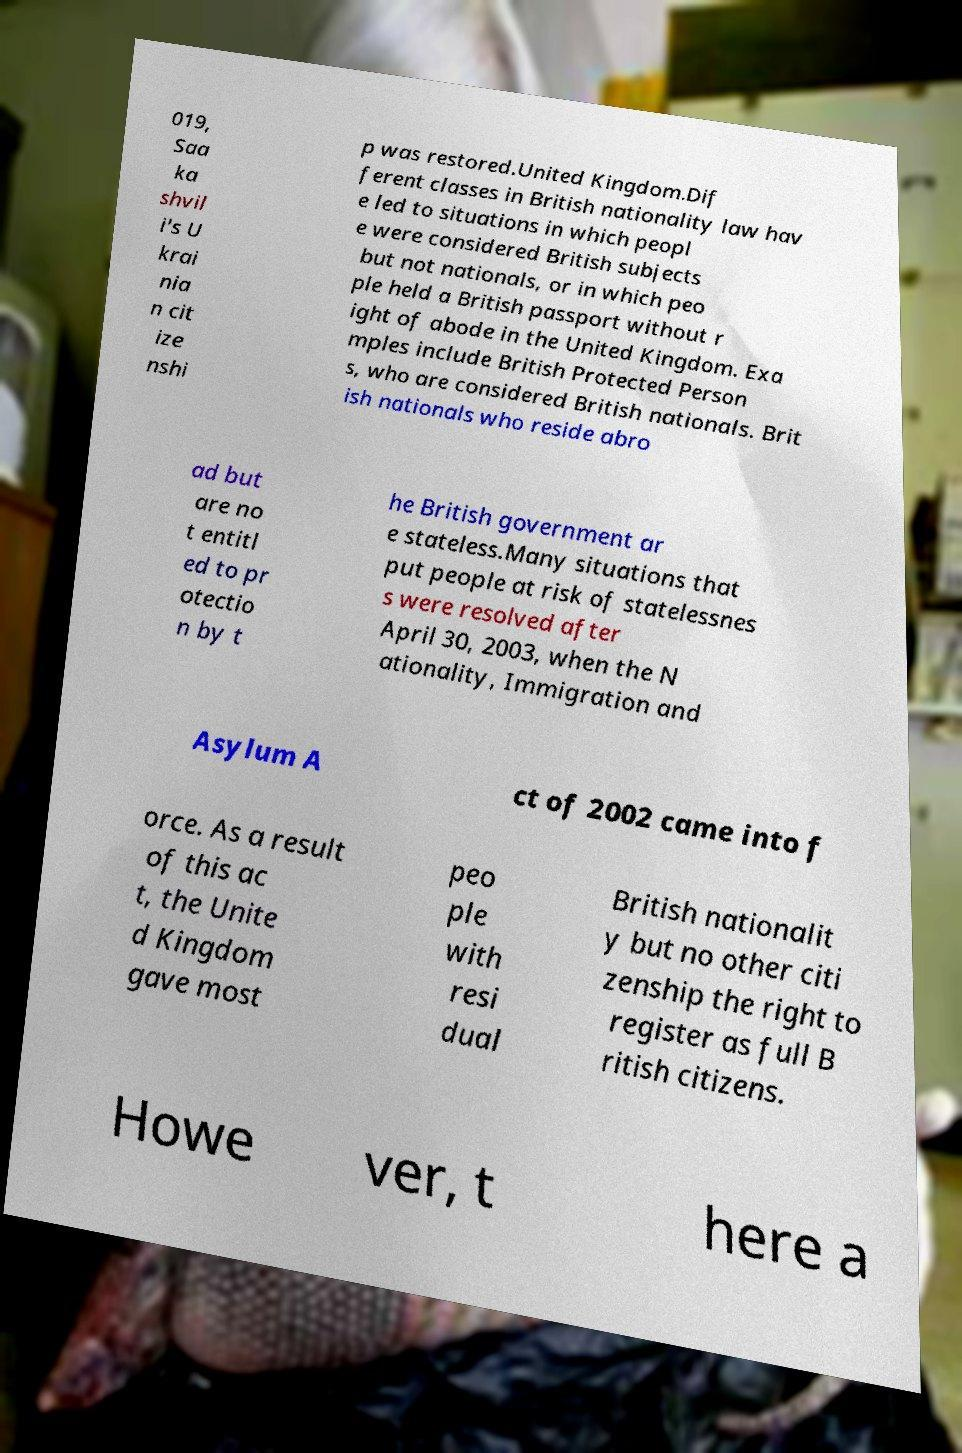For documentation purposes, I need the text within this image transcribed. Could you provide that? 019, Saa ka shvil i's U krai nia n cit ize nshi p was restored.United Kingdom.Dif ferent classes in British nationality law hav e led to situations in which peopl e were considered British subjects but not nationals, or in which peo ple held a British passport without r ight of abode in the United Kingdom. Exa mples include British Protected Person s, who are considered British nationals. Brit ish nationals who reside abro ad but are no t entitl ed to pr otectio n by t he British government ar e stateless.Many situations that put people at risk of statelessnes s were resolved after April 30, 2003, when the N ationality, Immigration and Asylum A ct of 2002 came into f orce. As a result of this ac t, the Unite d Kingdom gave most peo ple with resi dual British nationalit y but no other citi zenship the right to register as full B ritish citizens. Howe ver, t here a 